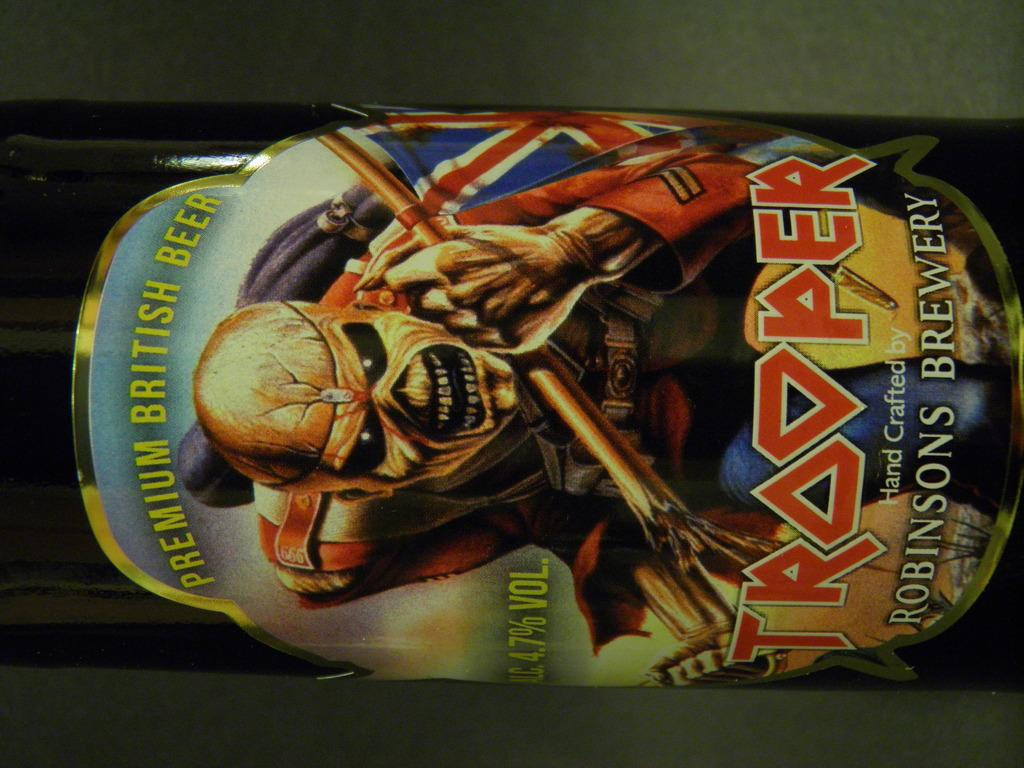What object can be seen in the image? There is a bottle in the image. Is there any additional detail on the bottle? Yes, there is a sticker on the bottle. How many apples are on the quilt in the image? There are no apples or quilt present in the image; it only features a bottle with a sticker on it. 